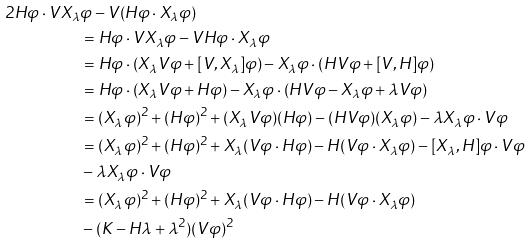<formula> <loc_0><loc_0><loc_500><loc_500>2 H \varphi \cdot V X _ { \lambda } & \varphi - V ( H \varphi \cdot X _ { \lambda } \varphi ) \\ & = H \varphi \cdot V X _ { \lambda } \varphi - V H \varphi \cdot X _ { \lambda } \varphi \\ & = H \varphi \cdot ( X _ { \lambda } V \varphi + [ V , X _ { \lambda } ] \varphi ) - X _ { \lambda } \varphi \cdot ( H V \varphi + [ V , H ] \varphi ) \\ & = H \varphi \cdot ( X _ { \lambda } V \varphi + H \varphi ) - X _ { \lambda } \varphi \cdot ( H V \varphi - X _ { \lambda } \varphi + \lambda V \varphi ) \\ & = ( X _ { \lambda } \varphi ) ^ { 2 } + ( H \varphi ) ^ { 2 } + ( X _ { \lambda } V \varphi ) ( H \varphi ) - ( H V \varphi ) ( X _ { \lambda } \varphi ) - \lambda X _ { \lambda } \varphi \cdot V \varphi \\ & = ( X _ { \lambda } \varphi ) ^ { 2 } + ( H \varphi ) ^ { 2 } + X _ { \lambda } ( V \varphi \cdot H \varphi ) - H ( V \varphi \cdot X _ { \lambda } \varphi ) - [ X _ { \lambda } , H ] \varphi \cdot V \varphi \\ & - \lambda X _ { \lambda } \varphi \cdot V \varphi \\ & = ( X _ { \lambda } \varphi ) ^ { 2 } + ( H \varphi ) ^ { 2 } + X _ { \lambda } ( V \varphi \cdot H \varphi ) - H ( V \varphi \cdot X _ { \lambda } \varphi ) \\ & - ( K - H \lambda + \lambda ^ { 2 } ) ( V \varphi ) ^ { 2 }</formula> 